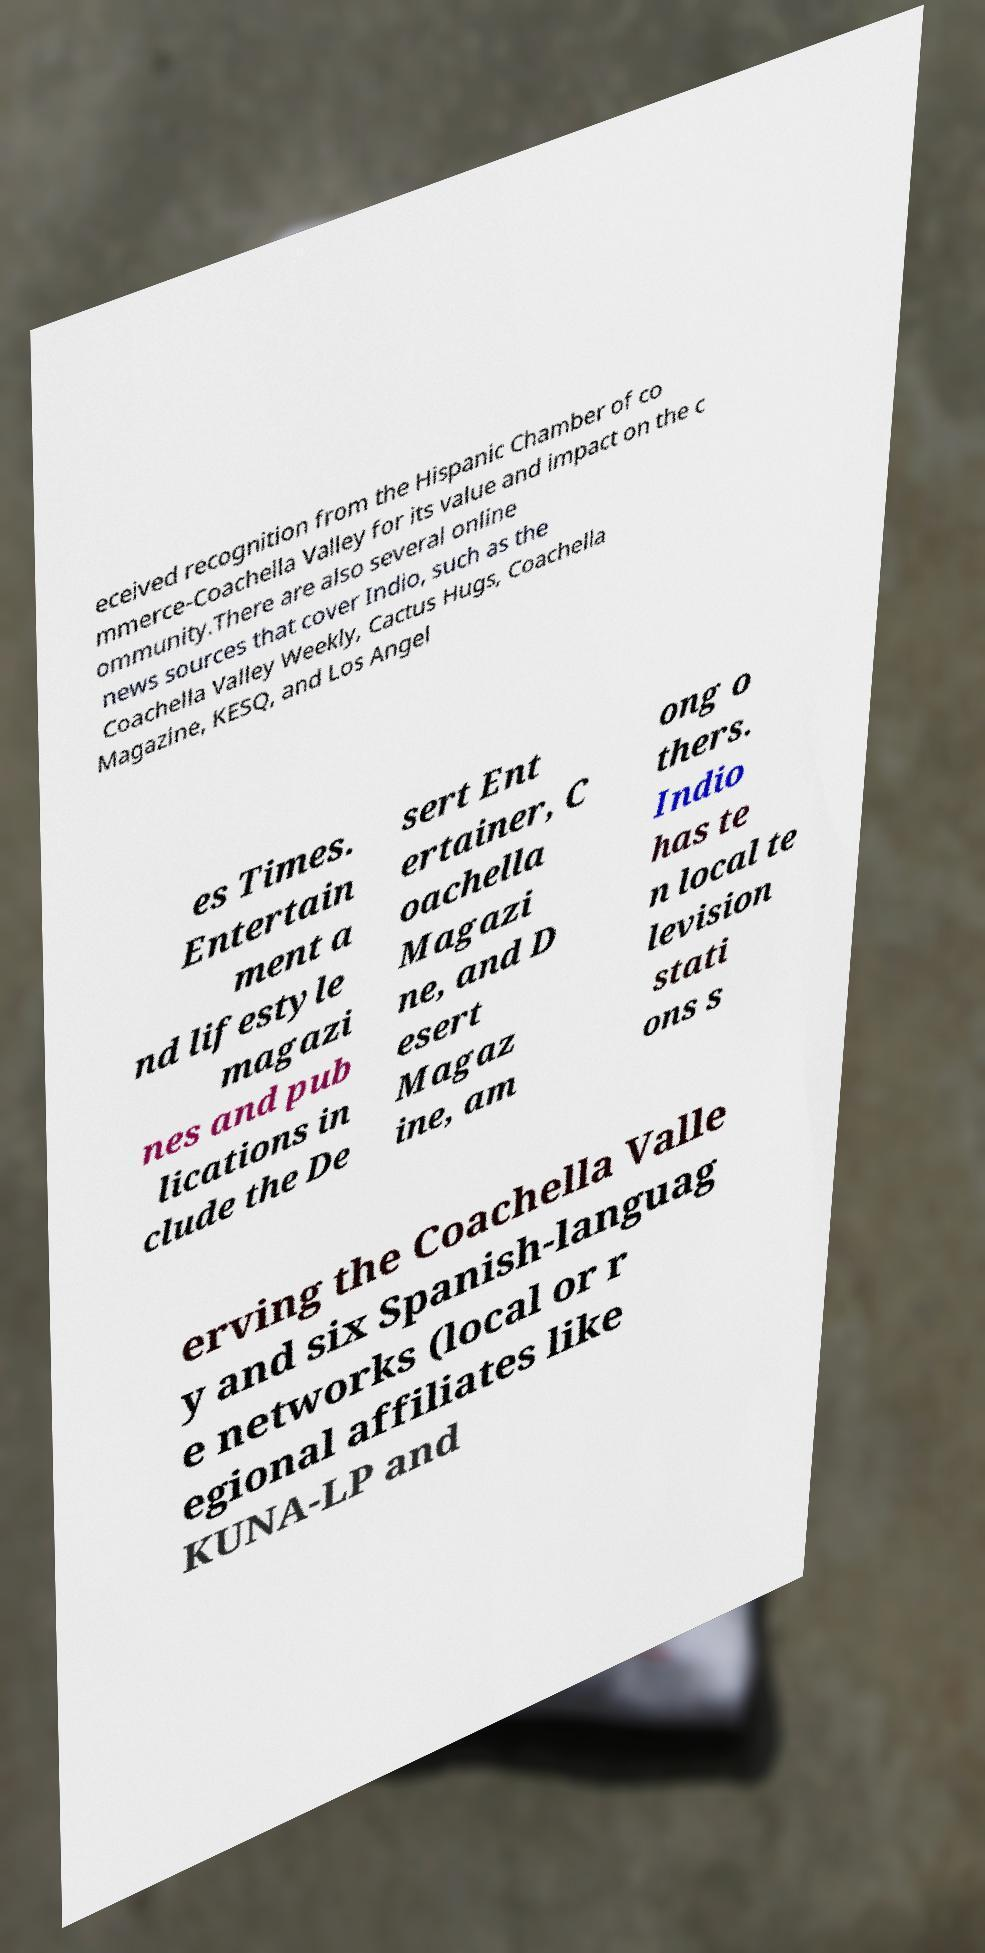There's text embedded in this image that I need extracted. Can you transcribe it verbatim? eceived recognition from the Hispanic Chamber of co mmerce-Coachella Valley for its value and impact on the c ommunity.There are also several online news sources that cover Indio, such as the Coachella Valley Weekly, Cactus Hugs, Coachella Magazine, KESQ, and Los Angel es Times. Entertain ment a nd lifestyle magazi nes and pub lications in clude the De sert Ent ertainer, C oachella Magazi ne, and D esert Magaz ine, am ong o thers. Indio has te n local te levision stati ons s erving the Coachella Valle y and six Spanish-languag e networks (local or r egional affiliates like KUNA-LP and 